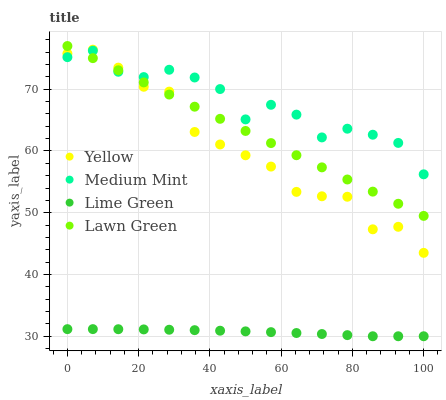Does Lime Green have the minimum area under the curve?
Answer yes or no. Yes. Does Medium Mint have the maximum area under the curve?
Answer yes or no. Yes. Does Lawn Green have the minimum area under the curve?
Answer yes or no. No. Does Lawn Green have the maximum area under the curve?
Answer yes or no. No. Is Lawn Green the smoothest?
Answer yes or no. Yes. Is Medium Mint the roughest?
Answer yes or no. Yes. Is Lime Green the smoothest?
Answer yes or no. No. Is Lime Green the roughest?
Answer yes or no. No. Does Lime Green have the lowest value?
Answer yes or no. Yes. Does Lawn Green have the lowest value?
Answer yes or no. No. Does Lawn Green have the highest value?
Answer yes or no. Yes. Does Lime Green have the highest value?
Answer yes or no. No. Is Lime Green less than Yellow?
Answer yes or no. Yes. Is Lawn Green greater than Lime Green?
Answer yes or no. Yes. Does Yellow intersect Medium Mint?
Answer yes or no. Yes. Is Yellow less than Medium Mint?
Answer yes or no. No. Is Yellow greater than Medium Mint?
Answer yes or no. No. Does Lime Green intersect Yellow?
Answer yes or no. No. 